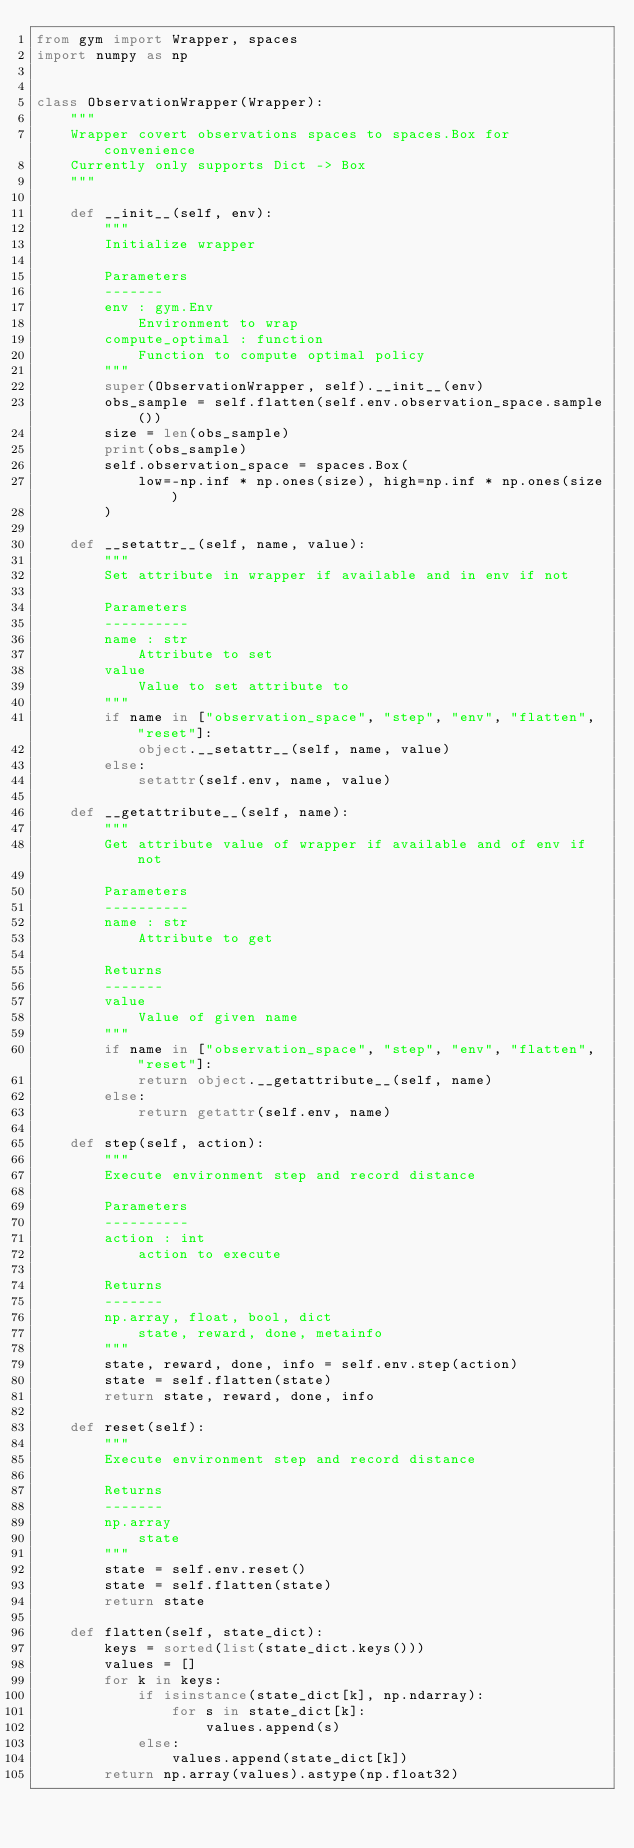Convert code to text. <code><loc_0><loc_0><loc_500><loc_500><_Python_>from gym import Wrapper, spaces
import numpy as np


class ObservationWrapper(Wrapper):
    """
    Wrapper covert observations spaces to spaces.Box for convenience
    Currently only supports Dict -> Box
    """

    def __init__(self, env):
        """
        Initialize wrapper

        Parameters
        -------
        env : gym.Env
            Environment to wrap
        compute_optimal : function
            Function to compute optimal policy
        """
        super(ObservationWrapper, self).__init__(env)
        obs_sample = self.flatten(self.env.observation_space.sample())
        size = len(obs_sample)
        print(obs_sample)
        self.observation_space = spaces.Box(
            low=-np.inf * np.ones(size), high=np.inf * np.ones(size)
        )

    def __setattr__(self, name, value):
        """
        Set attribute in wrapper if available and in env if not

        Parameters
        ----------
        name : str
            Attribute to set
        value
            Value to set attribute to
        """
        if name in ["observation_space", "step", "env", "flatten", "reset"]:
            object.__setattr__(self, name, value)
        else:
            setattr(self.env, name, value)

    def __getattribute__(self, name):
        """
        Get attribute value of wrapper if available and of env if not

        Parameters
        ----------
        name : str
            Attribute to get

        Returns
        -------
        value
            Value of given name
        """
        if name in ["observation_space", "step", "env", "flatten", "reset"]:
            return object.__getattribute__(self, name)
        else:
            return getattr(self.env, name)

    def step(self, action):
        """
        Execute environment step and record distance

        Parameters
        ----------
        action : int
            action to execute

        Returns
        -------
        np.array, float, bool, dict
            state, reward, done, metainfo
        """
        state, reward, done, info = self.env.step(action)
        state = self.flatten(state)
        return state, reward, done, info

    def reset(self):
        """
        Execute environment step and record distance

        Returns
        -------
        np.array
            state
        """
        state = self.env.reset()
        state = self.flatten(state)
        return state

    def flatten(self, state_dict):
        keys = sorted(list(state_dict.keys()))
        values = []
        for k in keys:
            if isinstance(state_dict[k], np.ndarray):
                for s in state_dict[k]:
                    values.append(s)
            else:
                values.append(state_dict[k])
        return np.array(values).astype(np.float32)
</code> 